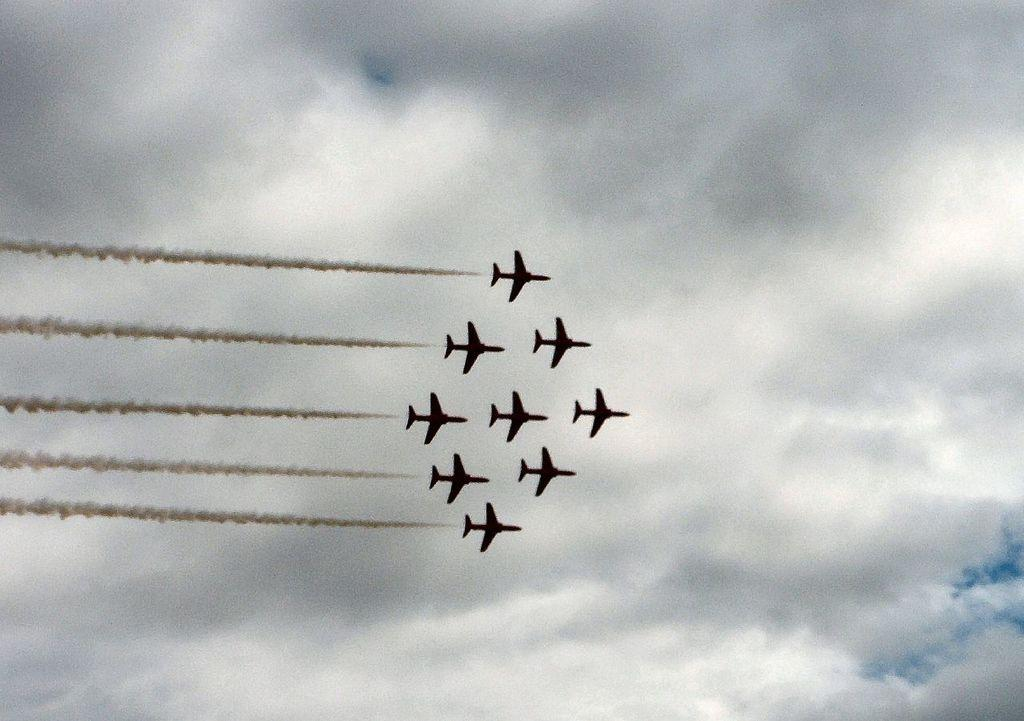What is the main subject of the image? The main subject of the image is planes. What are the planes doing in the image? The planes are producing smoke in the image. Where is the smoke visible in the image? The smoke is visible in the sky. What language is spoken by the smoke in the image? The smoke in the image does not speak any language, as it is a natural occurrence and not a sentient being. 